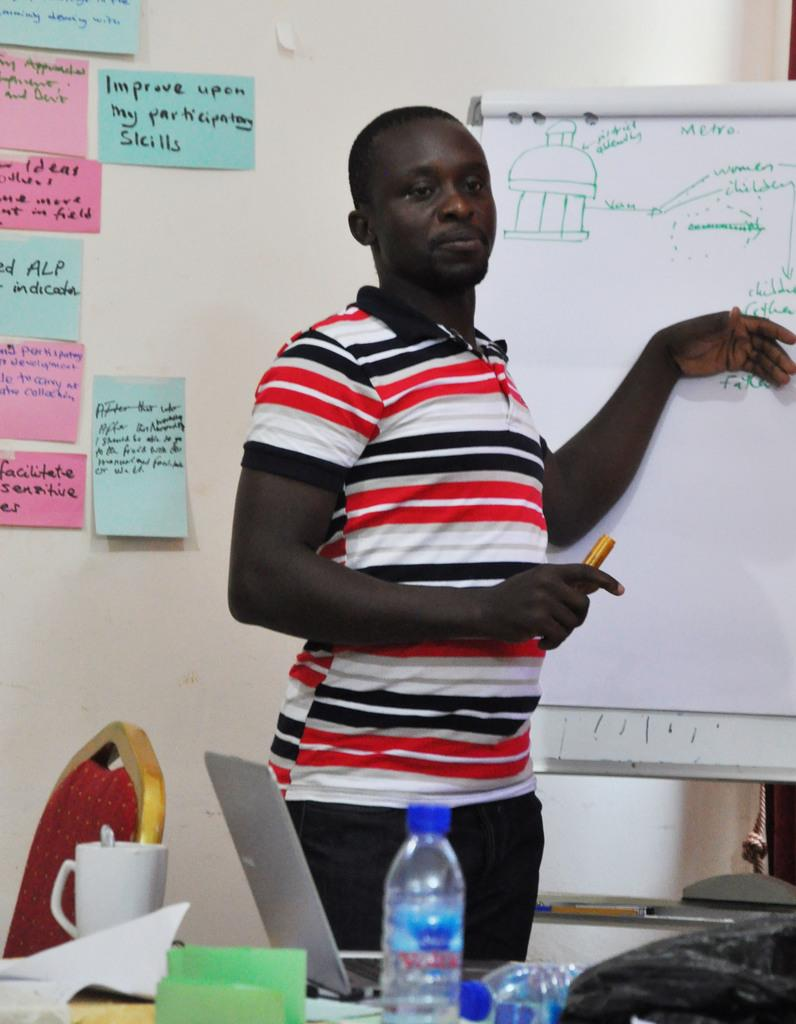<image>
Summarize the visual content of the image. A teacher is pointing to a whiteboard that says Metro. 